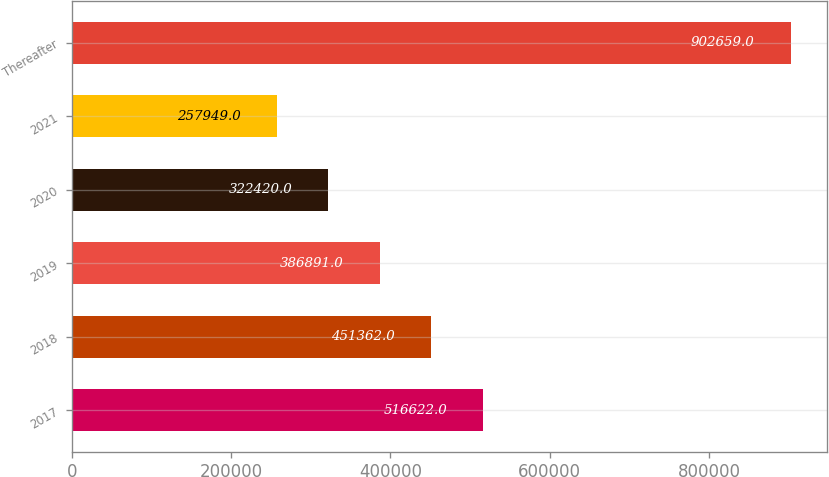<chart> <loc_0><loc_0><loc_500><loc_500><bar_chart><fcel>2017<fcel>2018<fcel>2019<fcel>2020<fcel>2021<fcel>Thereafter<nl><fcel>516622<fcel>451362<fcel>386891<fcel>322420<fcel>257949<fcel>902659<nl></chart> 